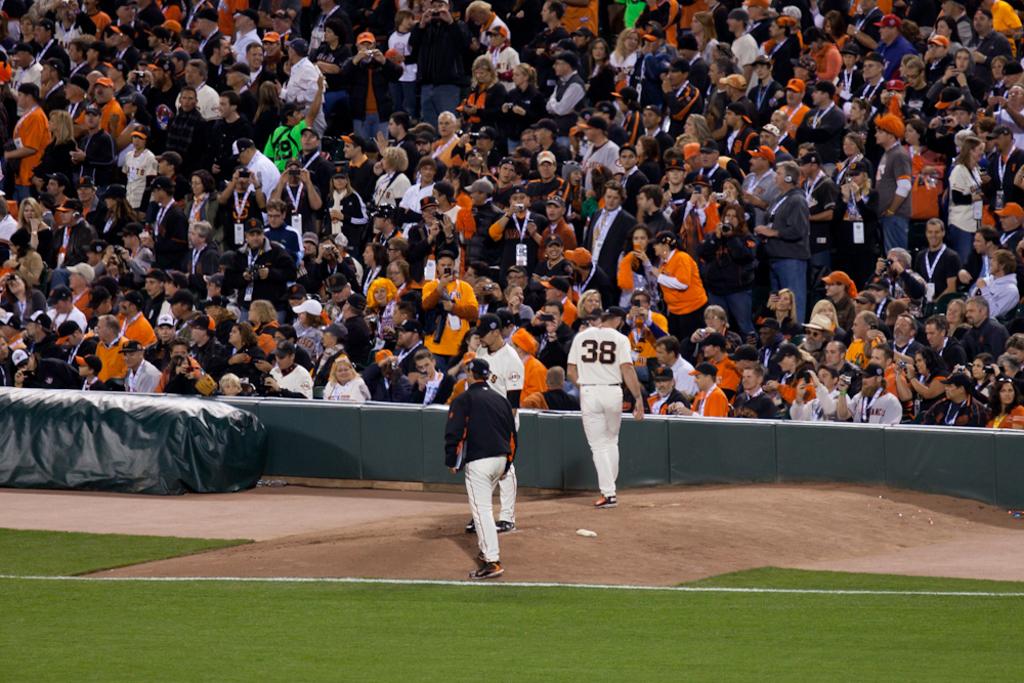What is the jersey number of the baseball player facing the crowd?
Your answer should be very brief. 38. 